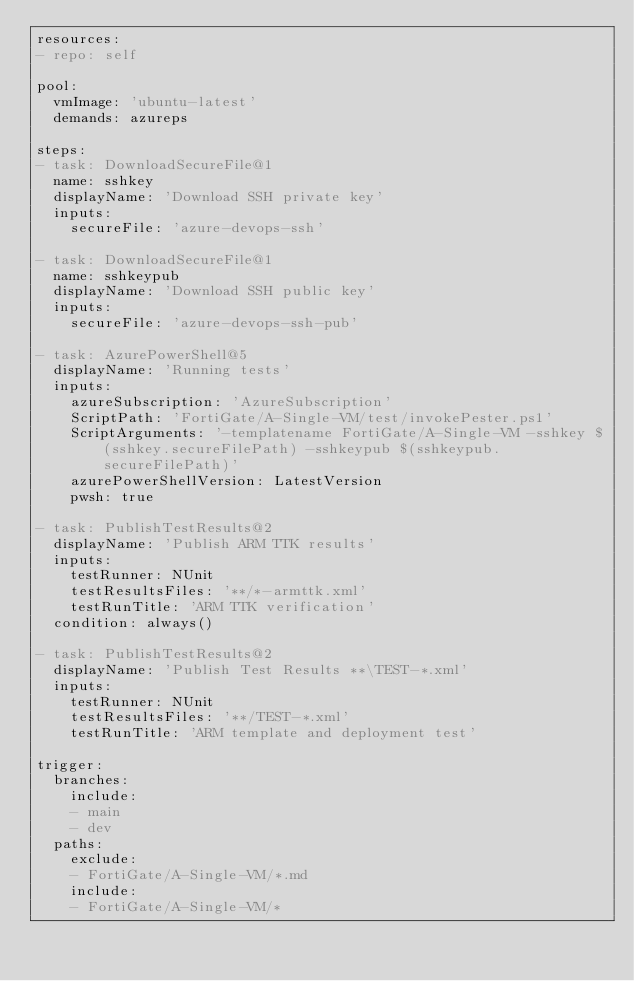<code> <loc_0><loc_0><loc_500><loc_500><_YAML_>resources:
- repo: self

pool:
  vmImage: 'ubuntu-latest'
  demands: azureps

steps:
- task: DownloadSecureFile@1
  name: sshkey
  displayName: 'Download SSH private key'
  inputs:
    secureFile: 'azure-devops-ssh'

- task: DownloadSecureFile@1
  name: sshkeypub
  displayName: 'Download SSH public key'
  inputs:
    secureFile: 'azure-devops-ssh-pub'

- task: AzurePowerShell@5
  displayName: 'Running tests'
  inputs:
    azureSubscription: 'AzureSubscription'
    ScriptPath: 'FortiGate/A-Single-VM/test/invokePester.ps1'
    ScriptArguments: '-templatename FortiGate/A-Single-VM -sshkey $(sshkey.secureFilePath) -sshkeypub $(sshkeypub.secureFilePath)'
    azurePowerShellVersion: LatestVersion
    pwsh: true

- task: PublishTestResults@2
  displayName: 'Publish ARM TTK results'
  inputs:
    testRunner: NUnit
    testResultsFiles: '**/*-armttk.xml'
    testRunTitle: 'ARM TTK verification'
  condition: always()

- task: PublishTestResults@2
  displayName: 'Publish Test Results **\TEST-*.xml'
  inputs:
    testRunner: NUnit
    testResultsFiles: '**/TEST-*.xml'
    testRunTitle: 'ARM template and deployment test'

trigger:
  branches:
    include:
    - main
    - dev
  paths:
    exclude:
    - FortiGate/A-Single-VM/*.md
    include:
    - FortiGate/A-Single-VM/*
</code> 